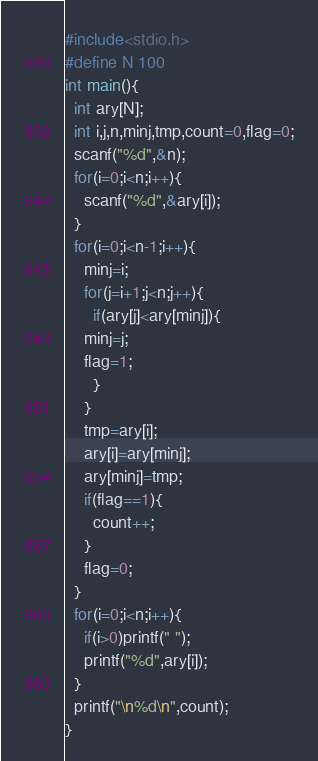<code> <loc_0><loc_0><loc_500><loc_500><_C_>#include<stdio.h>
#define N 100
int main(){
  int ary[N];
  int i,j,n,minj,tmp,count=0,flag=0;
  scanf("%d",&n);
  for(i=0;i<n;i++){
    scanf("%d",&ary[i]);
  }
  for(i=0;i<n-1;i++){
    minj=i;
    for(j=i+1;j<n;j++){
      if(ary[j]<ary[minj]){
	minj=j;
	flag=1;
      }
    }
    tmp=ary[i];
    ary[i]=ary[minj];
    ary[minj]=tmp;
    if(flag==1){
      count++;
    }
    flag=0;
  }
  for(i=0;i<n;i++){
    if(i>0)printf(" ");
    printf("%d",ary[i]);
  }
  printf("\n%d\n",count);
}

</code> 